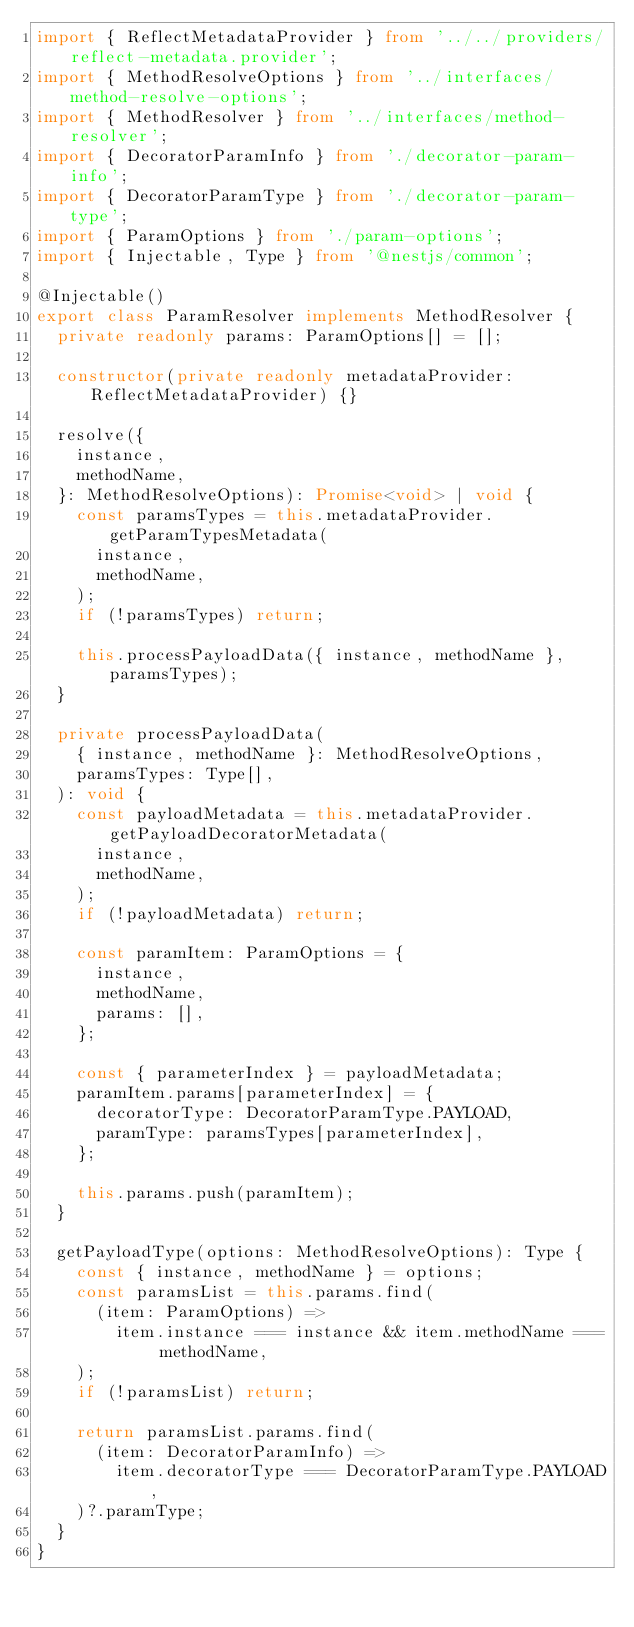Convert code to text. <code><loc_0><loc_0><loc_500><loc_500><_TypeScript_>import { ReflectMetadataProvider } from '../../providers/reflect-metadata.provider';
import { MethodResolveOptions } from '../interfaces/method-resolve-options';
import { MethodResolver } from '../interfaces/method-resolver';
import { DecoratorParamInfo } from './decorator-param-info';
import { DecoratorParamType } from './decorator-param-type';
import { ParamOptions } from './param-options';
import { Injectable, Type } from '@nestjs/common';

@Injectable()
export class ParamResolver implements MethodResolver {
  private readonly params: ParamOptions[] = [];

  constructor(private readonly metadataProvider: ReflectMetadataProvider) {}

  resolve({
    instance,
    methodName,
  }: MethodResolveOptions): Promise<void> | void {
    const paramsTypes = this.metadataProvider.getParamTypesMetadata(
      instance,
      methodName,
    );
    if (!paramsTypes) return;

    this.processPayloadData({ instance, methodName }, paramsTypes);
  }

  private processPayloadData(
    { instance, methodName }: MethodResolveOptions,
    paramsTypes: Type[],
  ): void {
    const payloadMetadata = this.metadataProvider.getPayloadDecoratorMetadata(
      instance,
      methodName,
    );
    if (!payloadMetadata) return;

    const paramItem: ParamOptions = {
      instance,
      methodName,
      params: [],
    };

    const { parameterIndex } = payloadMetadata;
    paramItem.params[parameterIndex] = {
      decoratorType: DecoratorParamType.PAYLOAD,
      paramType: paramsTypes[parameterIndex],
    };

    this.params.push(paramItem);
  }

  getPayloadType(options: MethodResolveOptions): Type {
    const { instance, methodName } = options;
    const paramsList = this.params.find(
      (item: ParamOptions) =>
        item.instance === instance && item.methodName === methodName,
    );
    if (!paramsList) return;

    return paramsList.params.find(
      (item: DecoratorParamInfo) =>
        item.decoratorType === DecoratorParamType.PAYLOAD,
    )?.paramType;
  }
}
</code> 